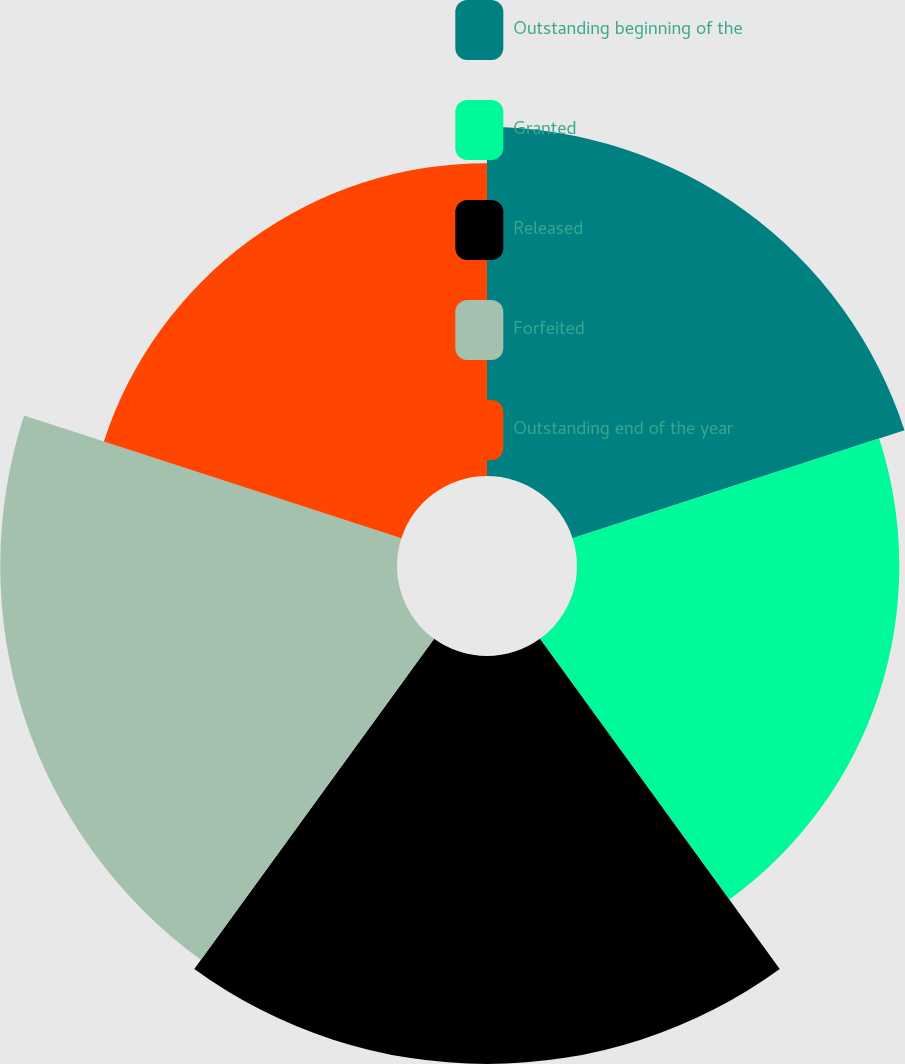Convert chart. <chart><loc_0><loc_0><loc_500><loc_500><pie_chart><fcel>Outstanding beginning of the<fcel>Granted<fcel>Released<fcel>Forfeited<fcel>Outstanding end of the year<nl><fcel>19.51%<fcel>18.02%<fcel>22.81%<fcel>22.18%<fcel>17.49%<nl></chart> 